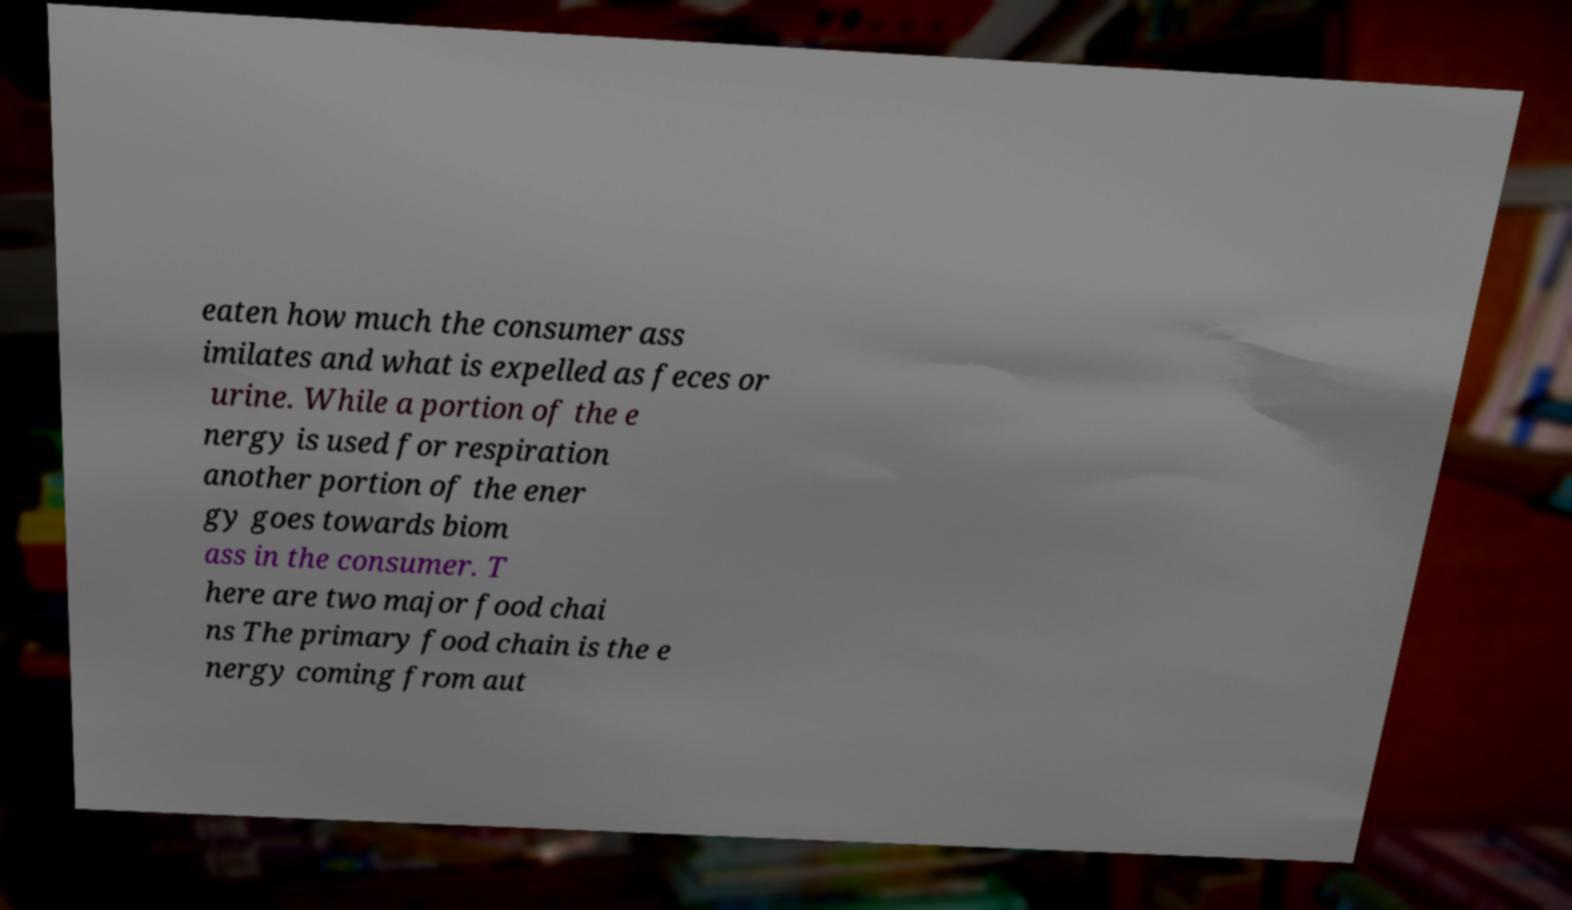Can you accurately transcribe the text from the provided image for me? eaten how much the consumer ass imilates and what is expelled as feces or urine. While a portion of the e nergy is used for respiration another portion of the ener gy goes towards biom ass in the consumer. T here are two major food chai ns The primary food chain is the e nergy coming from aut 